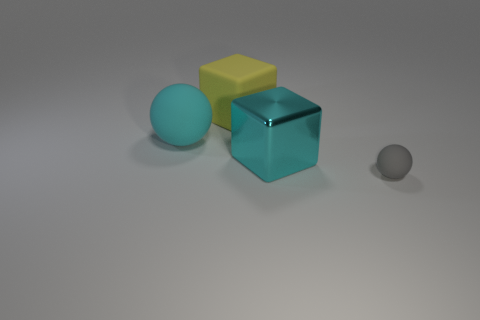Is there anything else that is made of the same material as the large cyan cube?
Give a very brief answer. No. Is the number of tiny gray rubber spheres that are to the left of the gray sphere greater than the number of large yellow matte cubes on the right side of the large cyan ball?
Offer a very short reply. No. There is a big cube that is in front of the cyan matte sphere; what material is it?
Offer a terse response. Metal. There is a small matte thing; is its shape the same as the cyan thing to the left of the cyan block?
Keep it short and to the point. Yes. There is a rubber sphere behind the rubber sphere that is in front of the large cyan metallic cube; what number of blocks are behind it?
Keep it short and to the point. 1. What color is the other large thing that is the same shape as the yellow rubber object?
Your answer should be compact. Cyan. Are there any other things that are the same shape as the large cyan matte object?
Your response must be concise. Yes. How many cylinders are small brown things or tiny gray things?
Provide a short and direct response. 0. The yellow matte thing has what shape?
Your response must be concise. Cube. There is a metallic thing; are there any spheres left of it?
Your answer should be very brief. Yes. 